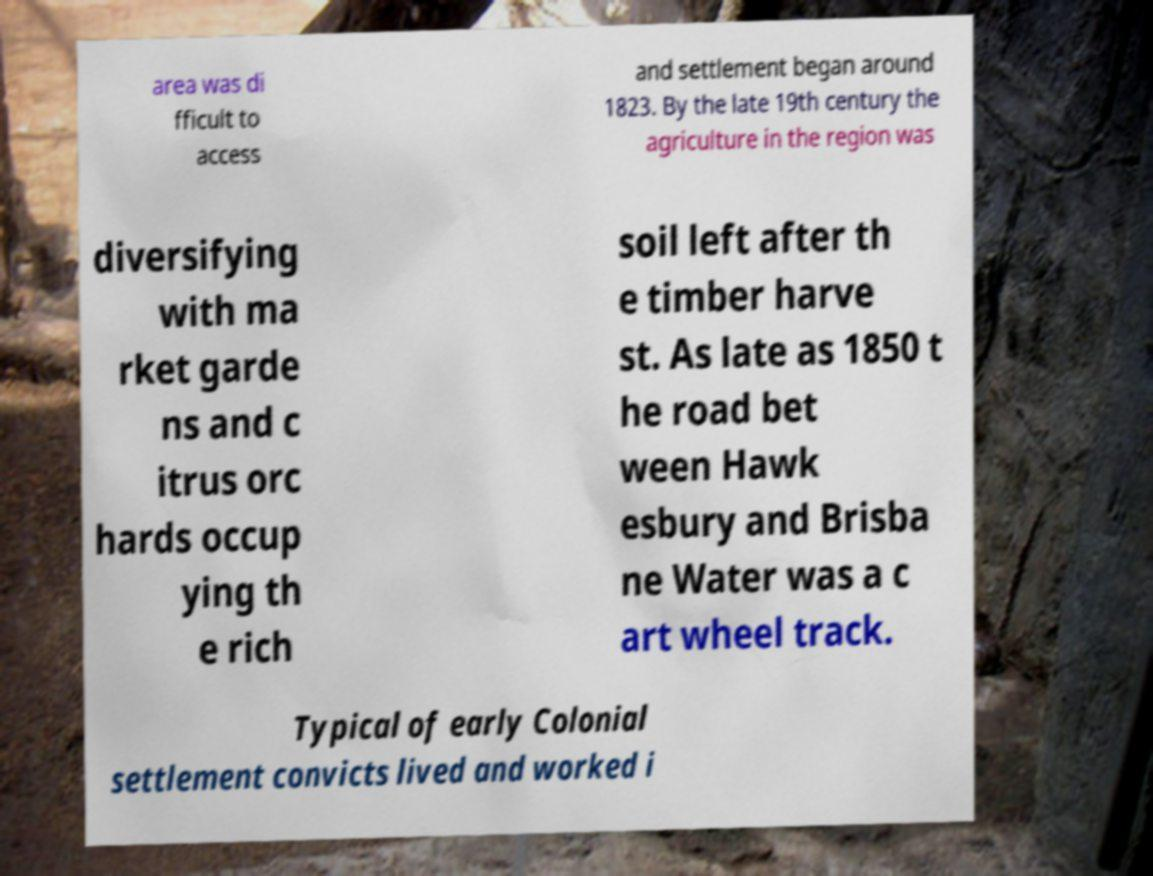Please read and relay the text visible in this image. What does it say? area was di fficult to access and settlement began around 1823. By the late 19th century the agriculture in the region was diversifying with ma rket garde ns and c itrus orc hards occup ying th e rich soil left after th e timber harve st. As late as 1850 t he road bet ween Hawk esbury and Brisba ne Water was a c art wheel track. Typical of early Colonial settlement convicts lived and worked i 